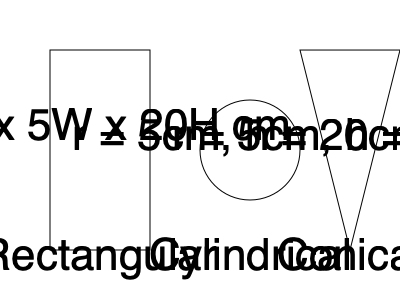As a plant manager overseeing battery production, you need to estimate the total volume of electrolyte required for a batch of 1000 batteries. Each battery requires three containers of electrolyte: one rectangular, one cylindrical, and one conical, with dimensions as shown in the diagram. What is the total volume of electrolyte needed for this batch, in liters? To solve this problem, we need to calculate the volume of each container and then sum them up for the total electrolyte volume per battery. Finally, we'll multiply by the number of batteries in the batch.

1. Rectangular container:
   Volume = length × width × height
   $V_r = 10 \text{ cm} \times 5 \text{ cm} \times 20 \text{ cm} = 1000 \text{ cm}^3$

2. Cylindrical container:
   Volume = $\pi r^2 h$
   $V_c = \pi \times (5 \text{ cm})^2 \times 20 \text{ cm} = 500\pi \text{ cm}^3 \approx 1570.8 \text{ cm}^3$

3. Conical container:
   Volume = $\frac{1}{3} \pi r^2 h$
   $V_n = \frac{1}{3} \times \pi \times (5 \text{ cm})^2 \times 20 \text{ cm} = \frac{500\pi}{3} \text{ cm}^3 \approx 523.6 \text{ cm}^3$

4. Total volume per battery:
   $V_t = V_r + V_c + V_n = 1000 + 500\pi + \frac{500\pi}{3} \text{ cm}^3 \approx 3094.4 \text{ cm}^3$

5. Total volume for 1000 batteries:
   $V_{total} = 1000 \times 3094.4 \text{ cm}^3 = 3,094,400 \text{ cm}^3$

6. Convert to liters:
   $3,094,400 \text{ cm}^3 \times \frac{1 \text{ L}}{1000 \text{ cm}^3} = 3094.4 \text{ L}$

Therefore, the total volume of electrolyte needed for a batch of 1000 batteries is approximately 3094.4 liters.
Answer: 3094.4 L 